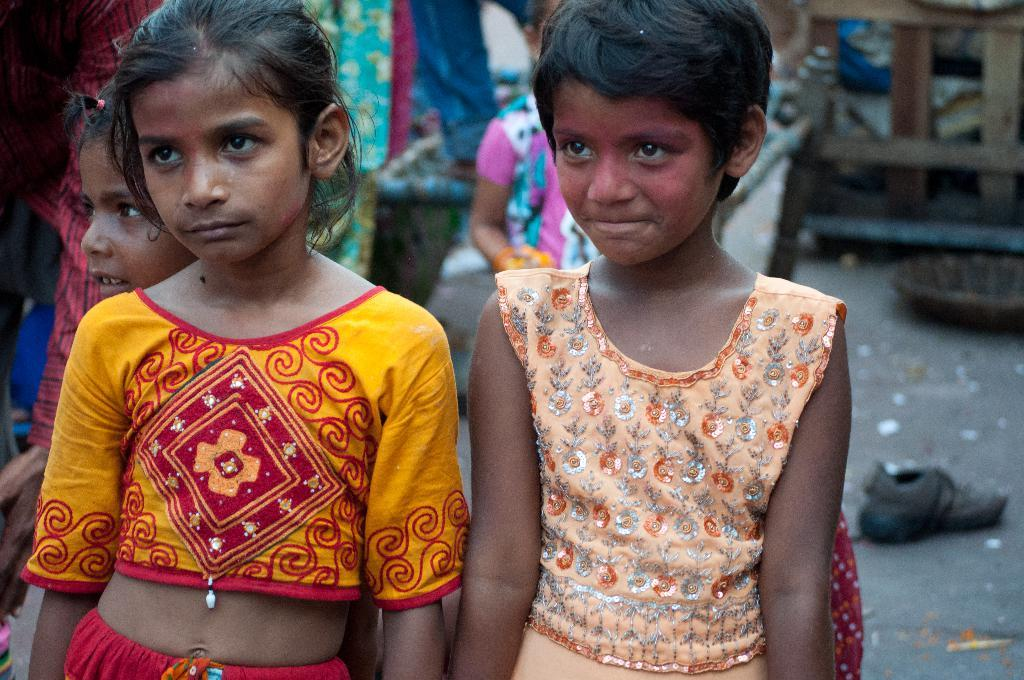How many girls are in the image? There are three girls in the image. Can you describe the background of the image? The background of the image is blurry. What else can be seen in the background besides the blurry scenery? There are people visible in the background, as well as a shoe and a basket. What type of top is the brother wearing in the image? There is no brother present in the image, and therefore no one is wearing a top. 